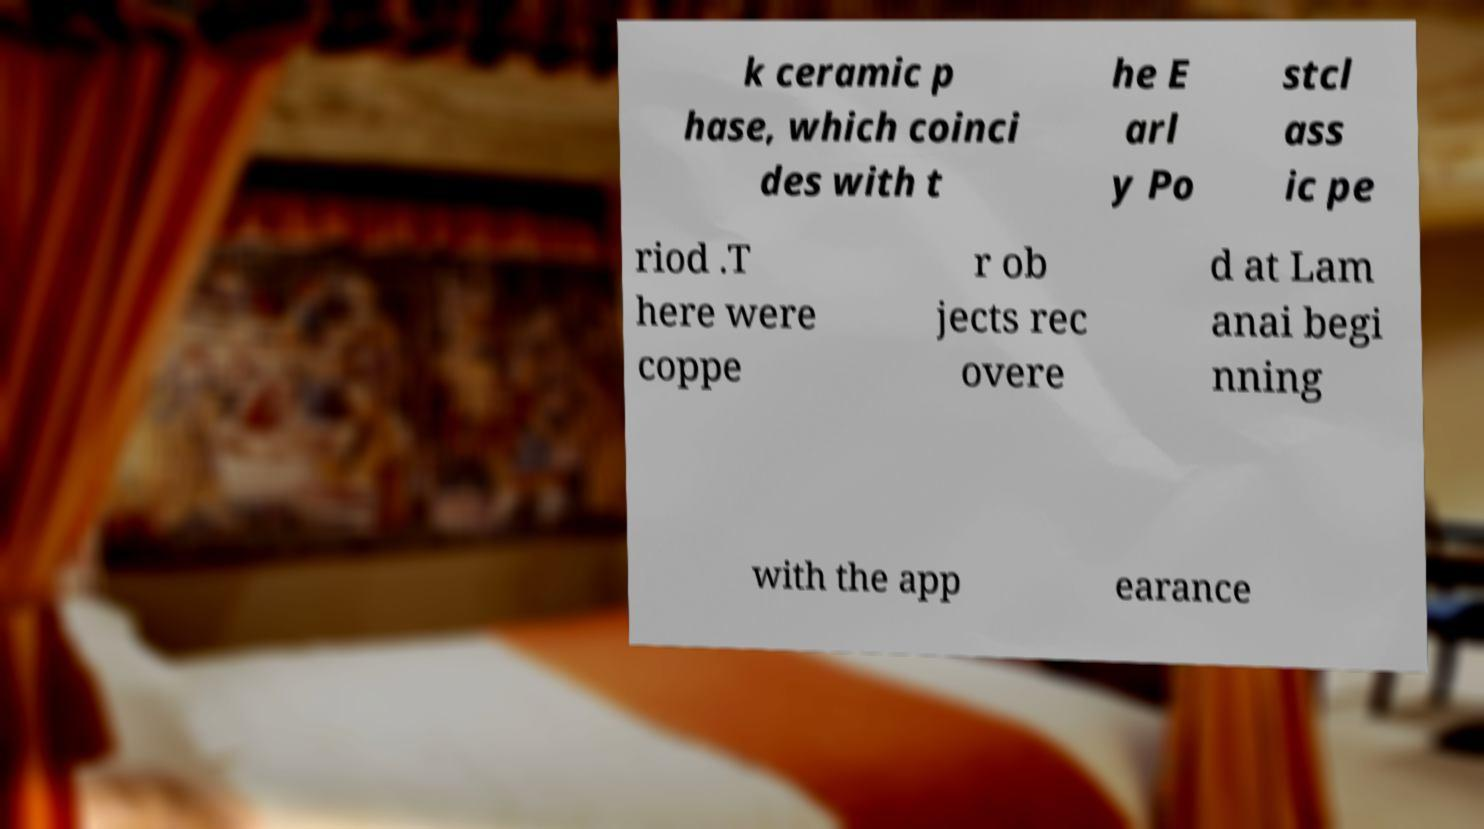What messages or text are displayed in this image? I need them in a readable, typed format. k ceramic p hase, which coinci des with t he E arl y Po stcl ass ic pe riod .T here were coppe r ob jects rec overe d at Lam anai begi nning with the app earance 